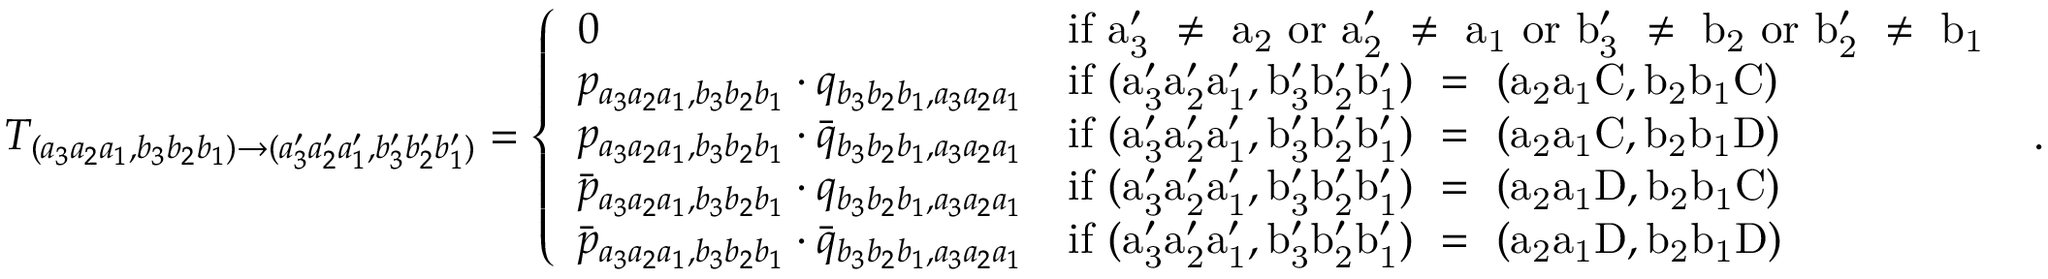<formula> <loc_0><loc_0><loc_500><loc_500>T _ { ( a _ { 3 } a _ { 2 } a _ { 1 } , b _ { 3 } b _ { 2 } b _ { 1 } ) \to ( a _ { 3 } ^ { \prime } a _ { 2 } ^ { \prime } a _ { 1 } ^ { \prime } , b _ { 3 } ^ { \prime } b _ { 2 } ^ { \prime } b _ { 1 } ^ { \prime } ) } = \left \{ \begin{array} { l l } { 0 } & { i f a _ { 3 } ^ { \prime } \neq a _ { 2 } o r a _ { 2 } ^ { \prime } \neq a _ { 1 } o r b _ { 3 } ^ { \prime } \neq b _ { 2 } o r b _ { 2 } ^ { \prime } \neq b _ { 1 } } \\ { p _ { a _ { 3 } a _ { 2 } a _ { 1 } , b _ { 3 } b _ { 2 } b _ { 1 } } \cdot q _ { b _ { 3 } b _ { 2 } b _ { 1 } , a _ { 3 } a _ { 2 } a _ { 1 } } } & { i f ( a _ { 3 } ^ { \prime } a _ { 2 } ^ { \prime } a _ { 1 } ^ { \prime } , b _ { 3 } ^ { \prime } b _ { 2 } ^ { \prime } b _ { 1 } ^ { \prime } ) = ( a _ { 2 } a _ { 1 } C , b _ { 2 } b _ { 1 } C ) } \\ { p _ { a _ { 3 } a _ { 2 } a _ { 1 } , b _ { 3 } b _ { 2 } b _ { 1 } } \cdot \bar { q } _ { b _ { 3 } b _ { 2 } b _ { 1 } , a _ { 3 } a _ { 2 } a _ { 1 } } } & { i f ( a _ { 3 } ^ { \prime } a _ { 2 } ^ { \prime } a _ { 1 } ^ { \prime } , b _ { 3 } ^ { \prime } b _ { 2 } ^ { \prime } b _ { 1 } ^ { \prime } ) = ( a _ { 2 } a _ { 1 } C , b _ { 2 } b _ { 1 } D ) } \\ { \bar { p } _ { a _ { 3 } a _ { 2 } a _ { 1 } , b _ { 3 } b _ { 2 } b _ { 1 } } \cdot q _ { b _ { 3 } b _ { 2 } b _ { 1 } , a _ { 3 } a _ { 2 } a _ { 1 } } } & { i f ( a _ { 3 } ^ { \prime } a _ { 2 } ^ { \prime } a _ { 1 } ^ { \prime } , b _ { 3 } ^ { \prime } b _ { 2 } ^ { \prime } b _ { 1 } ^ { \prime } ) = ( a _ { 2 } a _ { 1 } D , b _ { 2 } b _ { 1 } C ) } \\ { \bar { p } _ { a _ { 3 } a _ { 2 } a _ { 1 } , b _ { 3 } b _ { 2 } b _ { 1 } } \cdot \bar { q } _ { b _ { 3 } b _ { 2 } b _ { 1 } , a _ { 3 } a _ { 2 } a _ { 1 } } } & { i f ( a _ { 3 } ^ { \prime } a _ { 2 } ^ { \prime } a _ { 1 } ^ { \prime } , b _ { 3 } ^ { \prime } b _ { 2 } ^ { \prime } b _ { 1 } ^ { \prime } ) = ( a _ { 2 } a _ { 1 } D , b _ { 2 } b _ { 1 } D ) } \end{array} .</formula> 